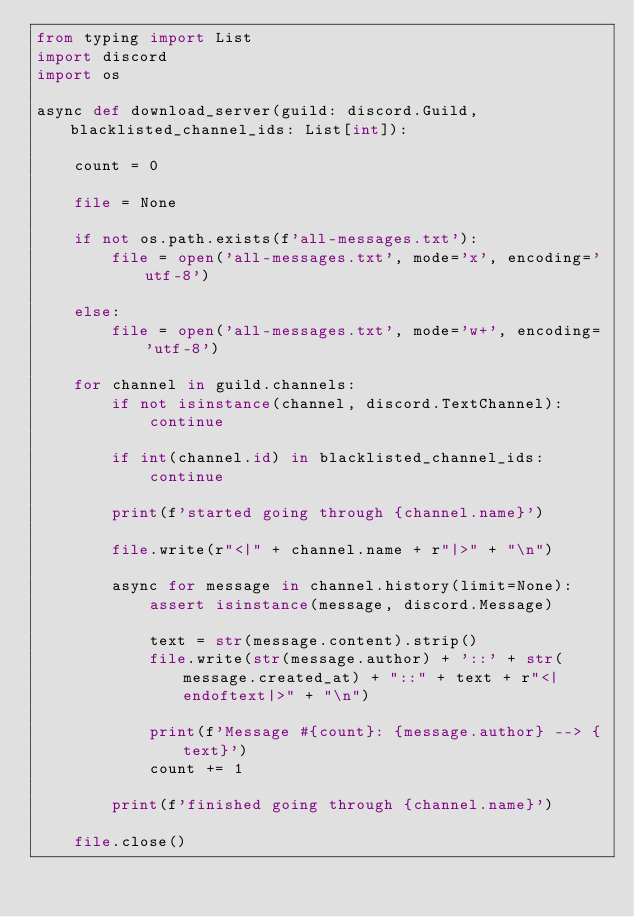<code> <loc_0><loc_0><loc_500><loc_500><_Python_>from typing import List
import discord
import os

async def download_server(guild: discord.Guild, blacklisted_channel_ids: List[int]):
    
    count = 0

    file = None

    if not os.path.exists(f'all-messages.txt'):
        file = open('all-messages.txt', mode='x', encoding='utf-8')

    else:
        file = open('all-messages.txt', mode='w+', encoding='utf-8')
    
    for channel in guild.channels:
        if not isinstance(channel, discord.TextChannel):
            continue
        
        if int(channel.id) in blacklisted_channel_ids:
            continue

        print(f'started going through {channel.name}')

        file.write(r"<|" + channel.name + r"|>" + "\n")

        async for message in channel.history(limit=None):
            assert isinstance(message, discord.Message)

            text = str(message.content).strip()
            file.write(str(message.author) + '::' + str(message.created_at) + "::" + text + r"<|endoftext|>" + "\n")

            print(f'Message #{count}: {message.author} --> {text}')
            count += 1

        print(f'finished going through {channel.name}')

    file.close()

</code> 